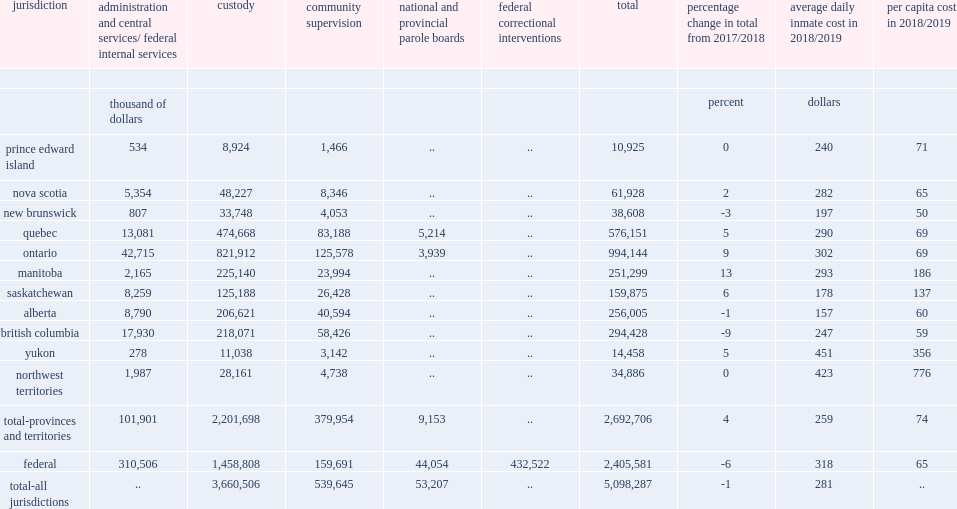Give me the full table as a dictionary. {'header': ['jurisdiction', 'administration and central services/ federal internal services', 'custody', 'community supervision', 'national and provincial parole boards', 'federal correctional interventions', 'total', 'percentage change in total from 2017/2018', 'average daily inmate cost in 2018/2019', 'per capita cost in 2018/2019'], 'rows': [['', '', '', '', '', '', '', '', '', ''], ['', 'thousand of dollars', '', '', '', '', '', 'percent', 'dollars', ''], ['prince edward island', '534', '8,924', '1,466', '..', '..', '10,925', '0', '240', '71'], ['nova scotia', '5,354', '48,227', '8,346', '..', '..', '61,928', '2', '282', '65'], ['new brunswick', '807', '33,748', '4,053', '..', '..', '38,608', '-3', '197', '50'], ['quebec', '13,081', '474,668', '83,188', '5,214', '..', '576,151', '5', '290', '69'], ['ontario', '42,715', '821,912', '125,578', '3,939', '..', '994,144', '9', '302', '69'], ['manitoba', '2,165', '225,140', '23,994', '..', '..', '251,299', '13', '293', '186'], ['saskatchewan', '8,259', '125,188', '26,428', '..', '..', '159,875', '6', '178', '137'], ['alberta', '8,790', '206,621', '40,594', '..', '..', '256,005', '-1', '157', '60'], ['british columbia', '17,930', '218,071', '58,426', '..', '..', '294,428', '-9', '247', '59'], ['yukon', '278', '11,038', '3,142', '..', '..', '14,458', '5', '451', '356'], ['northwest territories', '1,987', '28,161', '4,738', '..', '..', '34,886', '0', '423', '776'], ['total-provinces and territories', '101,901', '2,201,698', '379,954', '9,153', '..', '2,692,706', '4', '259', '74'], ['federal', '310,506', '1,458,808', '159,691', '44,054', '432,522', '2,405,581', '-6', '318', '65'], ['total-all jurisdictions', '..', '3,660,506', '539,645', '53,207', '..', '5,098,287', '-1', '281', '..']]} On average, in 2018/2019, how much of custodial services expenditures amounted per day per federal offender? 318.0. On average, in 2018/2019, how much of custodial services expenditures amounted per day per provincial/territorial offender? 259.0. 